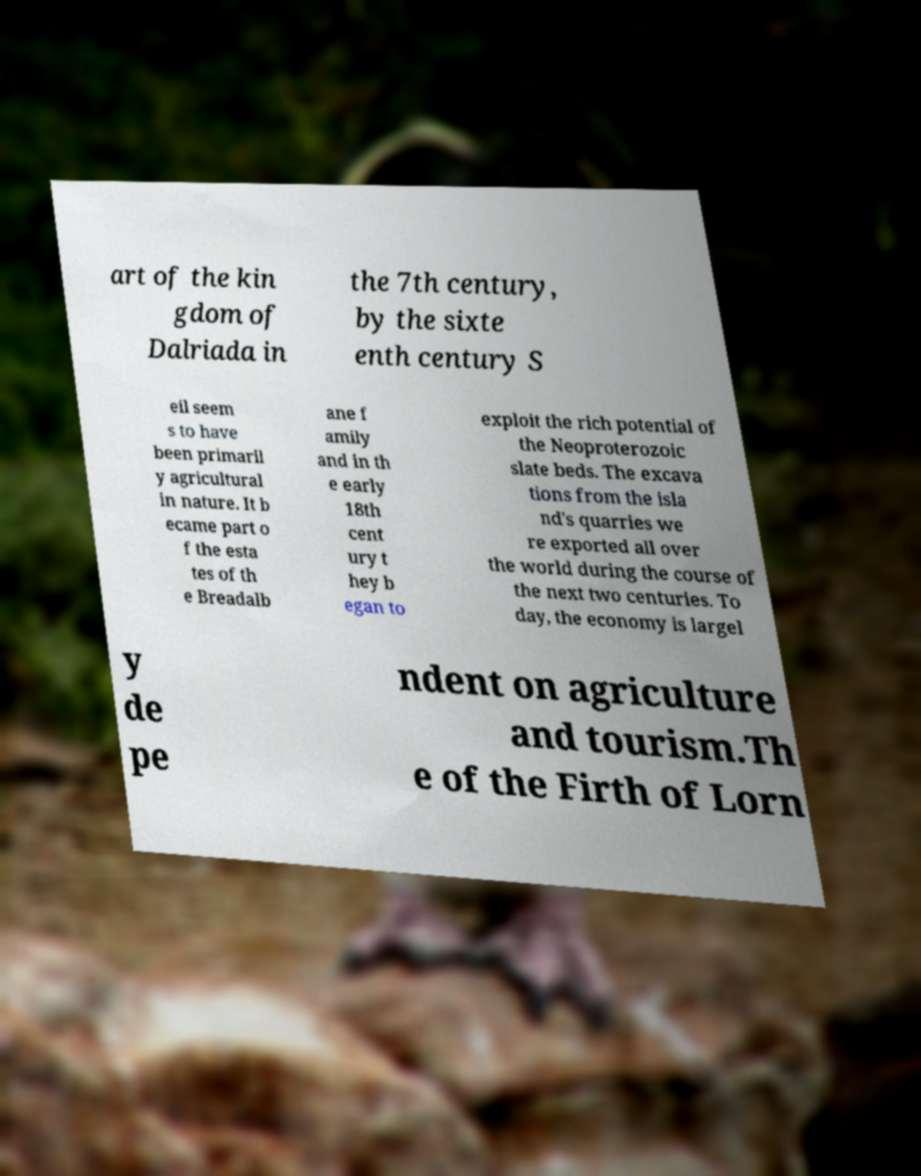Please identify and transcribe the text found in this image. art of the kin gdom of Dalriada in the 7th century, by the sixte enth century S eil seem s to have been primaril y agricultural in nature. It b ecame part o f the esta tes of th e Breadalb ane f amily and in th e early 18th cent ury t hey b egan to exploit the rich potential of the Neoproterozoic slate beds. The excava tions from the isla nd's quarries we re exported all over the world during the course of the next two centuries. To day, the economy is largel y de pe ndent on agriculture and tourism.Th e of the Firth of Lorn 